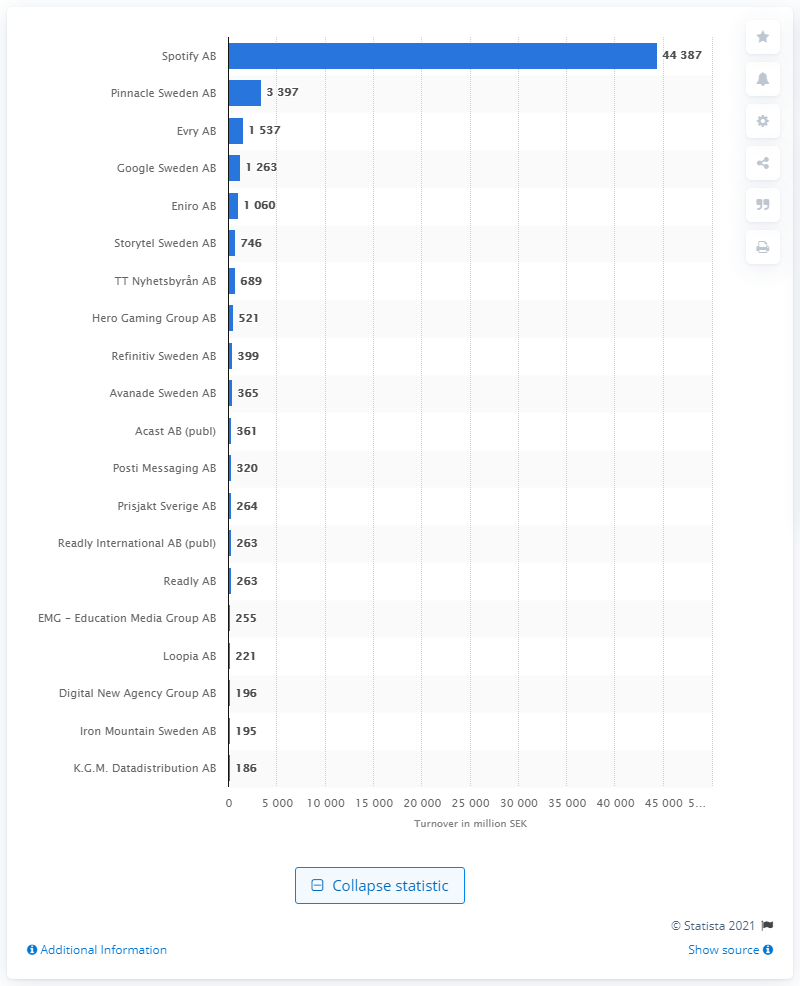Highlight a few significant elements in this photo. As of March 2021, Spotify AB was the leading company in the information services industry in Sweden. According to the latest information available as of March 2021, Pinnacle Sweden AB ranked second in the information services industry in Sweden. 